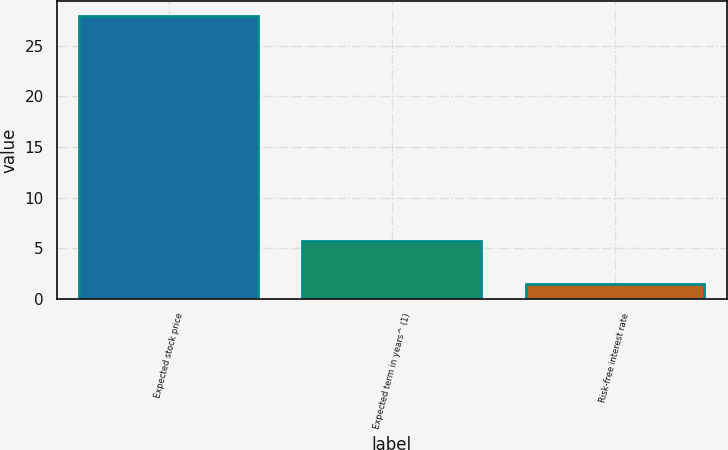<chart> <loc_0><loc_0><loc_500><loc_500><bar_chart><fcel>Expected stock price<fcel>Expected term in years^ (1)<fcel>Risk-free interest rate<nl><fcel>28<fcel>5.7<fcel>1.5<nl></chart> 